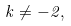Convert formula to latex. <formula><loc_0><loc_0><loc_500><loc_500>k \ne - 2 ,</formula> 